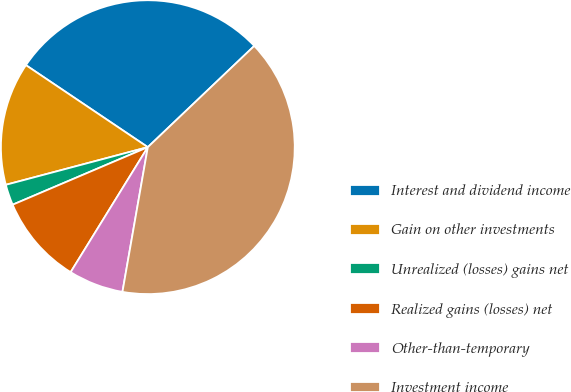Convert chart to OTSL. <chart><loc_0><loc_0><loc_500><loc_500><pie_chart><fcel>Interest and dividend income<fcel>Gain on other investments<fcel>Unrealized (losses) gains net<fcel>Realized gains (losses) net<fcel>Other-than-temporary<fcel>Investment income<nl><fcel>28.47%<fcel>13.55%<fcel>2.28%<fcel>9.79%<fcel>6.04%<fcel>39.86%<nl></chart> 